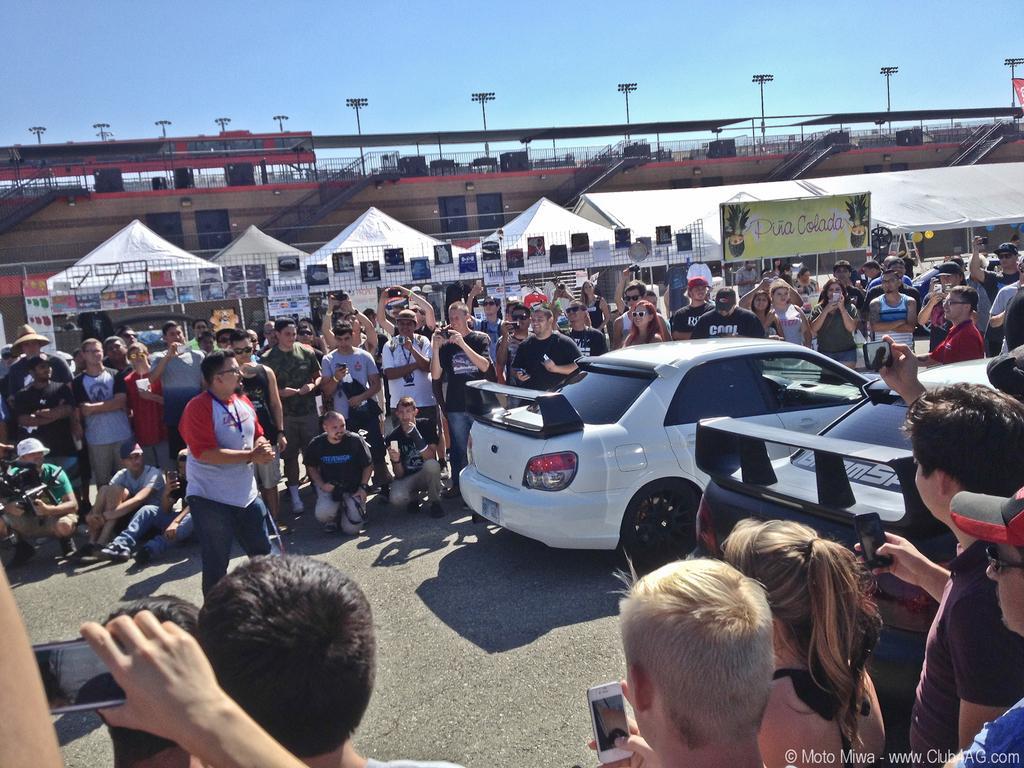Could you give a brief overview of what you see in this image? In this image I can see a road , on the road I can see vehicles and crowd of people and some people holding mobile on their hands , in the middle I can see fence and houses and poles and at the top I can see the sky. 